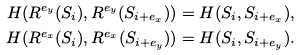Convert formula to latex. <formula><loc_0><loc_0><loc_500><loc_500>H ( R ^ { e _ { y } } ( S _ { i } ) , R ^ { e _ { y } } ( S _ { i + e _ { x } } ) ) & = H ( S _ { i } , S _ { i + e _ { x } } ) , \\ H ( R ^ { e _ { x } } ( S _ { i } ) , R ^ { e _ { x } } ( S _ { i + e _ { y } } ) ) & = H ( S _ { i } , S _ { i + e _ { y } } ) .</formula> 